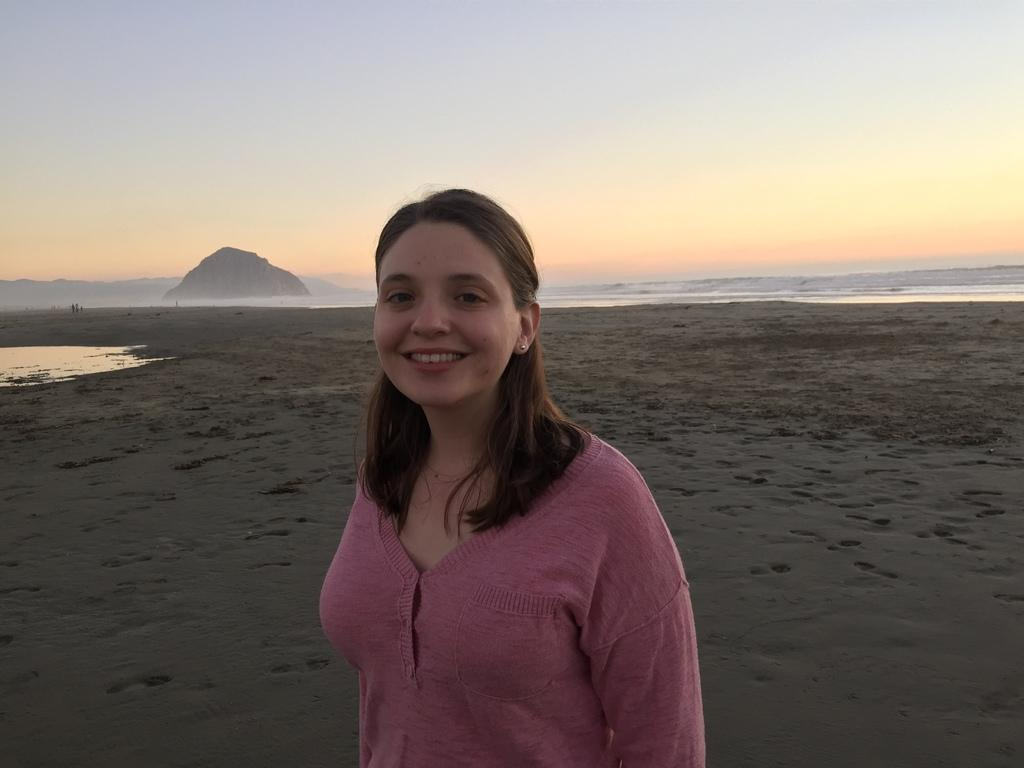Who or what is present in the image? There is a person in the image. What type of surface can be seen beneath the person? There is ground visible in the image. What is located on the ground? There are objects on the ground. What natural feature can be seen in the image? There is a hill in the image. What is visible above the person and the hill? The sky is visible in the image. Is there any water visible in the image? Yes, there is water visible in the image. What type of underwear is the person wearing in the image? There is no information about the person's underwear in the image, so it cannot be determined. 